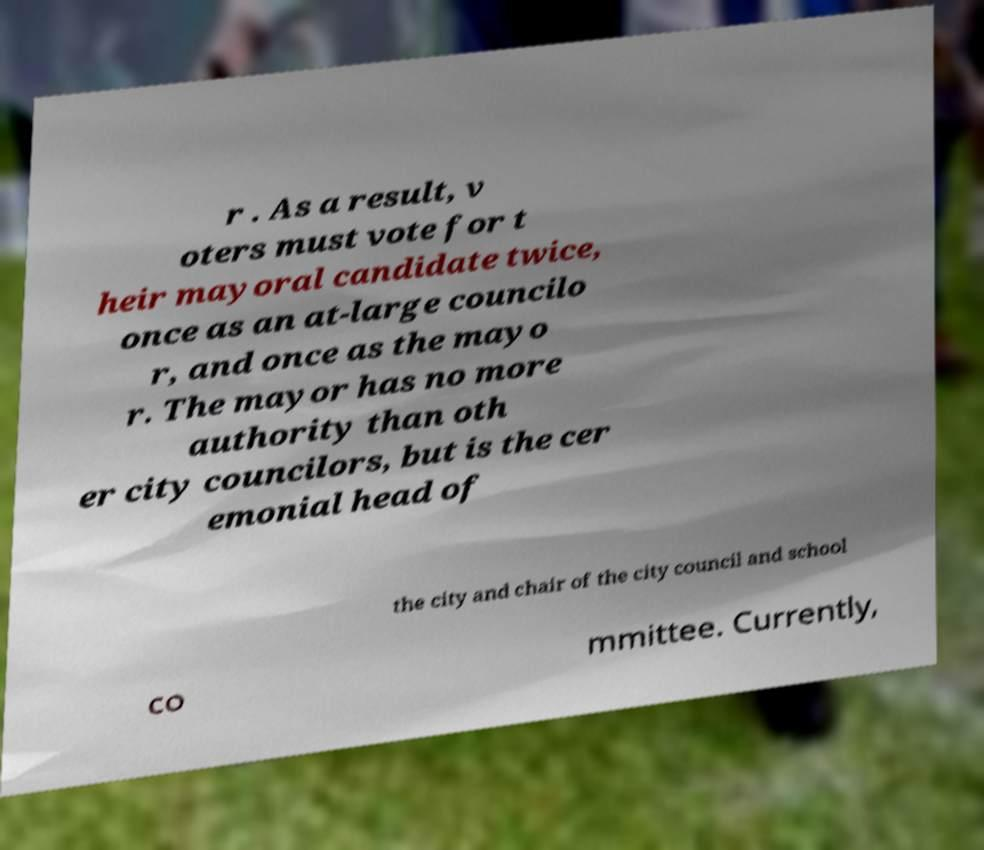What messages or text are displayed in this image? I need them in a readable, typed format. r . As a result, v oters must vote for t heir mayoral candidate twice, once as an at-large councilo r, and once as the mayo r. The mayor has no more authority than oth er city councilors, but is the cer emonial head of the city and chair of the city council and school co mmittee. Currently, 